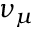Convert formula to latex. <formula><loc_0><loc_0><loc_500><loc_500>\nu _ { \mu }</formula> 